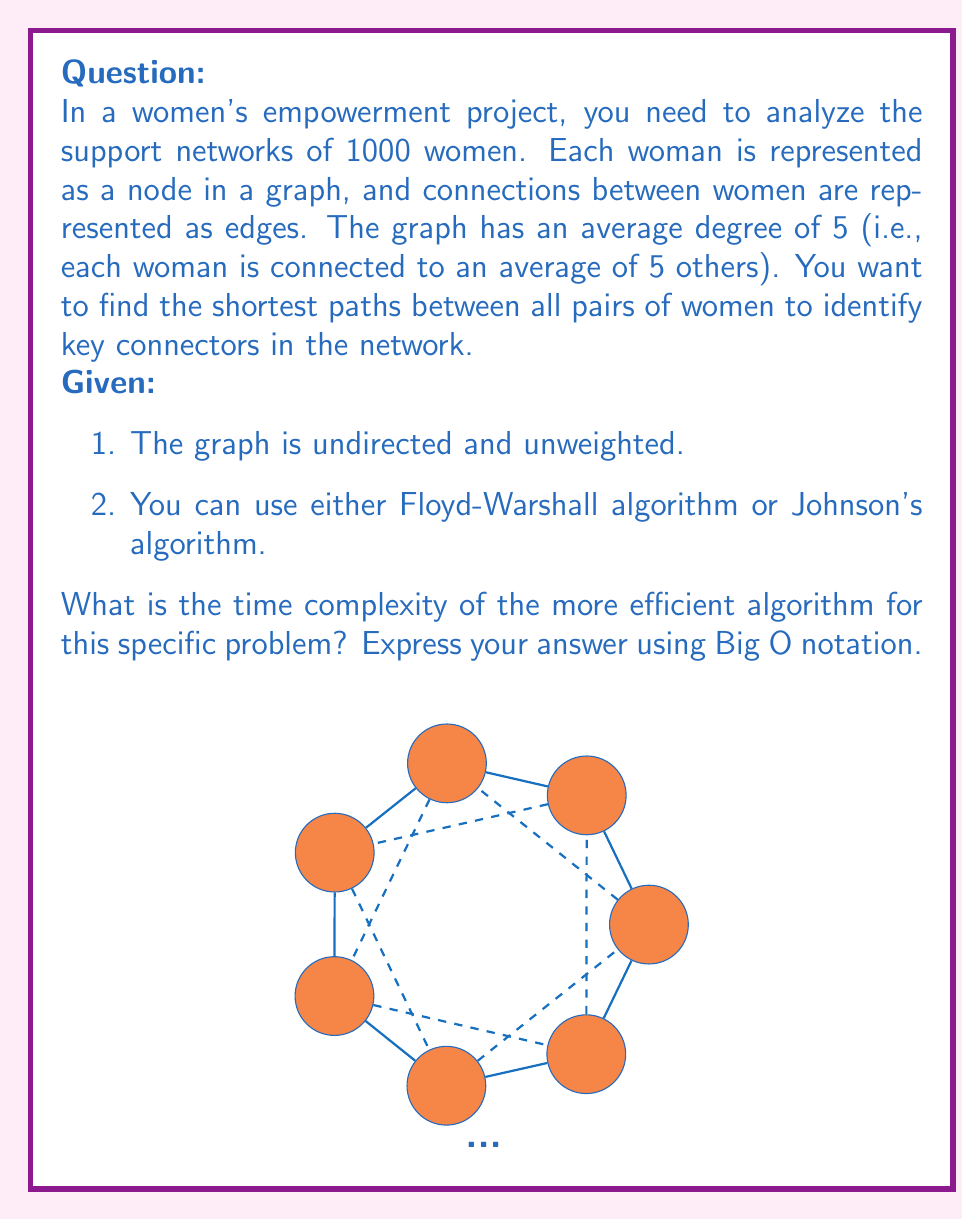Give your solution to this math problem. Let's approach this step-by-step:

1) First, we need to understand the input size:
   - Number of nodes (women) $n = 1000$
   - Number of edges $m = \frac{n \cdot 5}{2} = 2500$ (since each edge connects two women and the average degree is 5)

2) Now, let's consider the time complexities of both algorithms:
   
   a) Floyd-Warshall algorithm:
      - Time complexity: $O(n^3)$
      - For this problem: $O(1000^3) = O(10^9)$
   
   b) Johnson's algorithm:
      - Time complexity: $O(n^2 \log n + nm)$
      - For this problem: $O(1000^2 \log 1000 + 1000 \cdot 2500)$
                        $= O(10^6 \cdot 10 + 2.5 \cdot 10^6)$
                        $= O(10^7 + 2.5 \cdot 10^6)$
                        $\approx O(1.25 \cdot 10^7)$

3) Comparing the two:
   - Floyd-Warshall: $O(10^9)$
   - Johnson's: $O(1.25 \cdot 10^7)$

4) Clearly, Johnson's algorithm is more efficient for this specific problem.

5) The time complexity of Johnson's algorithm can be simplified to $O(n^2 \log n)$ because:
   - $n^2 \log n = 10^6 \cdot 10 = 10^7$
   - $nm = 2.5 \cdot 10^6$, which is smaller than $n^2 \log n$

Therefore, the time complexity of the more efficient algorithm (Johnson's) for this specific problem is $O(n^2 \log n)$.
Answer: $O(n^2 \log n)$ 